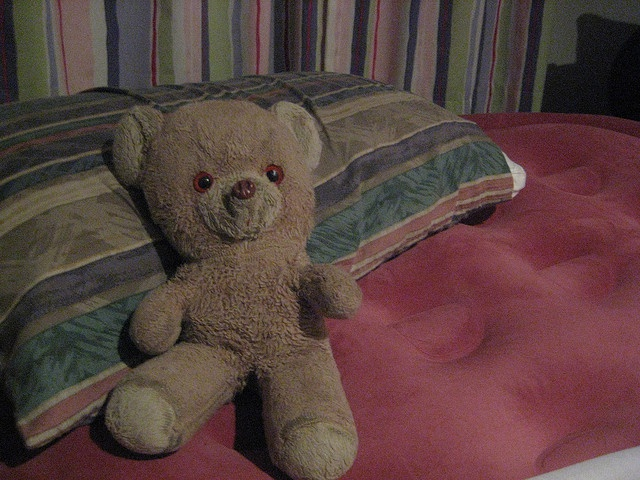Describe the objects in this image and their specific colors. I can see bed in black, maroon, gray, and brown tones and teddy bear in black and gray tones in this image. 